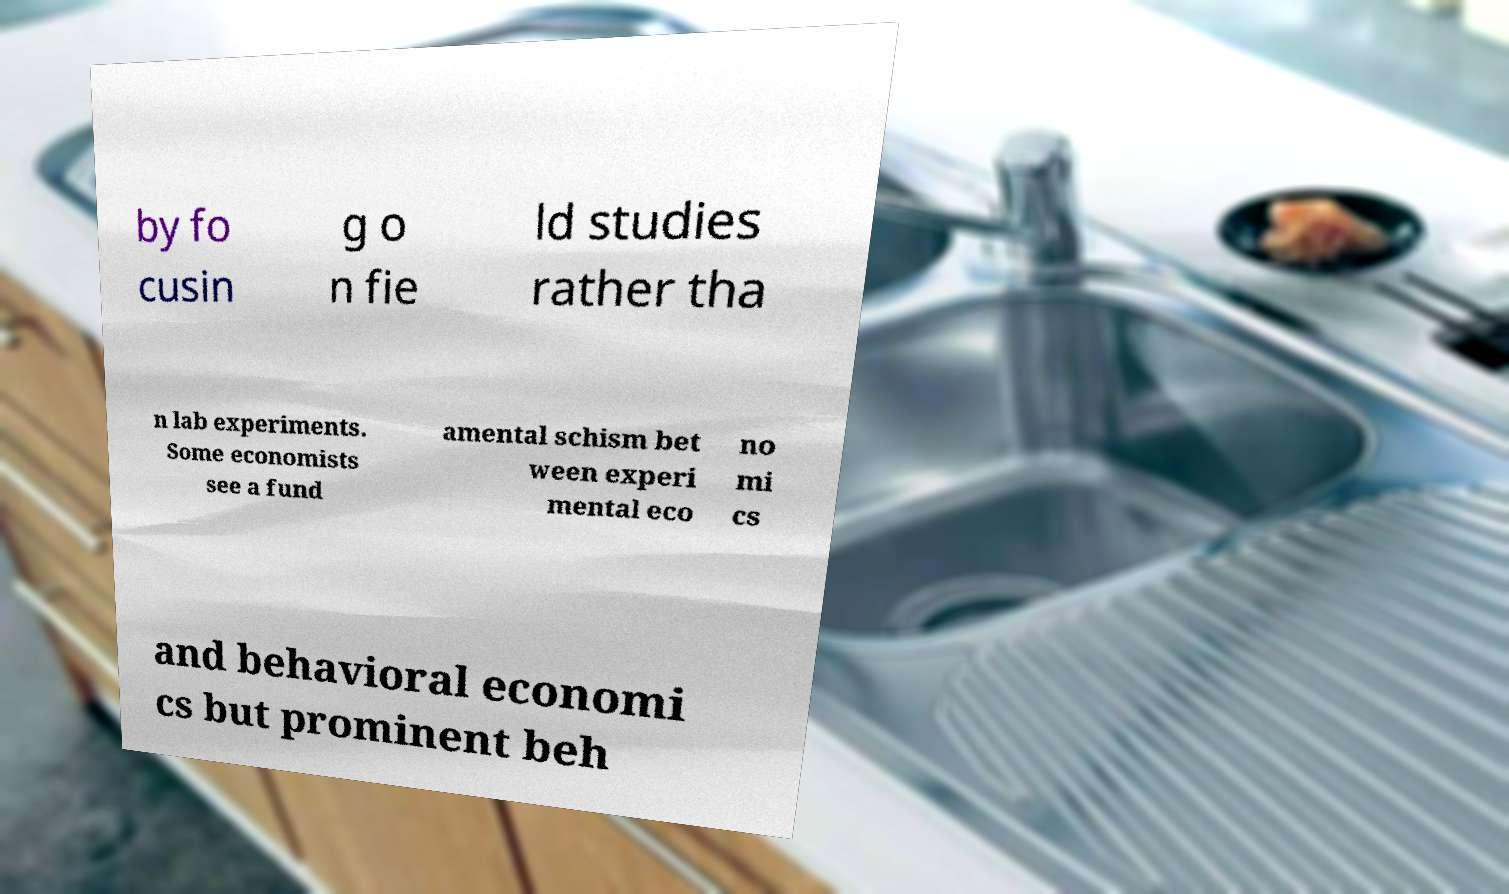For documentation purposes, I need the text within this image transcribed. Could you provide that? by fo cusin g o n fie ld studies rather tha n lab experiments. Some economists see a fund amental schism bet ween experi mental eco no mi cs and behavioral economi cs but prominent beh 